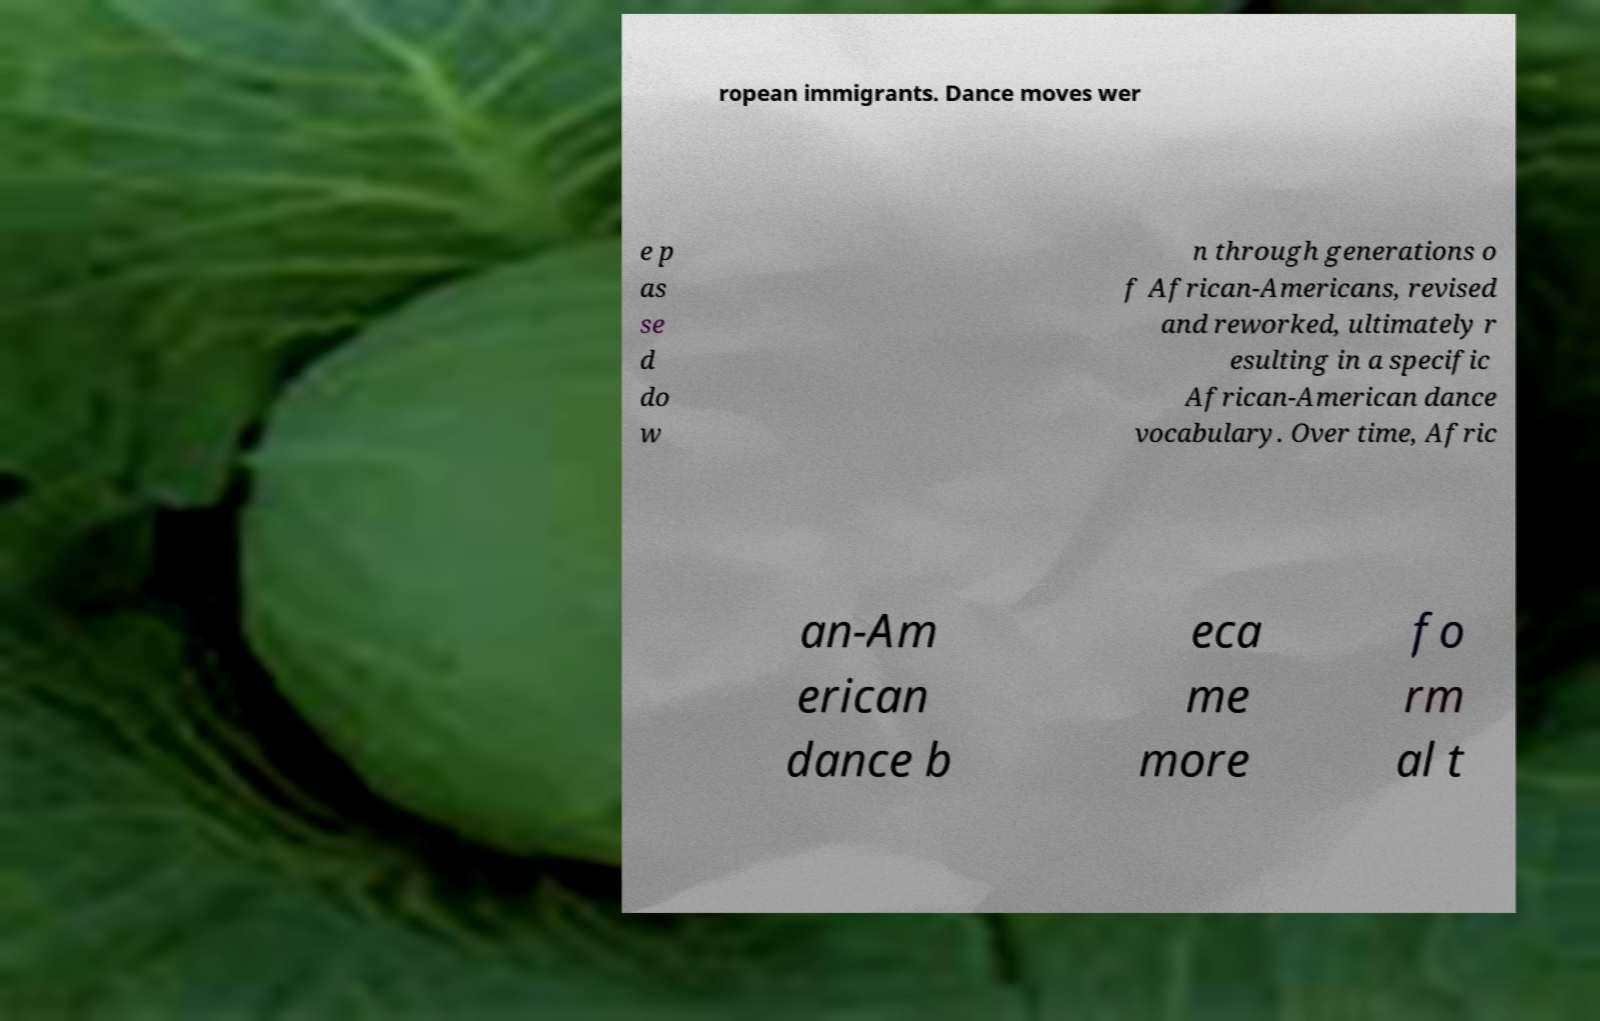There's text embedded in this image that I need extracted. Can you transcribe it verbatim? ropean immigrants. Dance moves wer e p as se d do w n through generations o f African-Americans, revised and reworked, ultimately r esulting in a specific African-American dance vocabulary. Over time, Afric an-Am erican dance b eca me more fo rm al t 